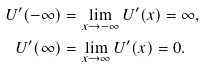<formula> <loc_0><loc_0><loc_500><loc_500>U ^ { \prime } ( - \infty ) & = \lim _ { x \rightarrow - \infty } U ^ { \prime } ( x ) = \infty , \\ U ^ { \prime } ( \infty ) & = \lim _ { x \rightarrow \infty } U ^ { \prime } ( x ) = 0 .</formula> 